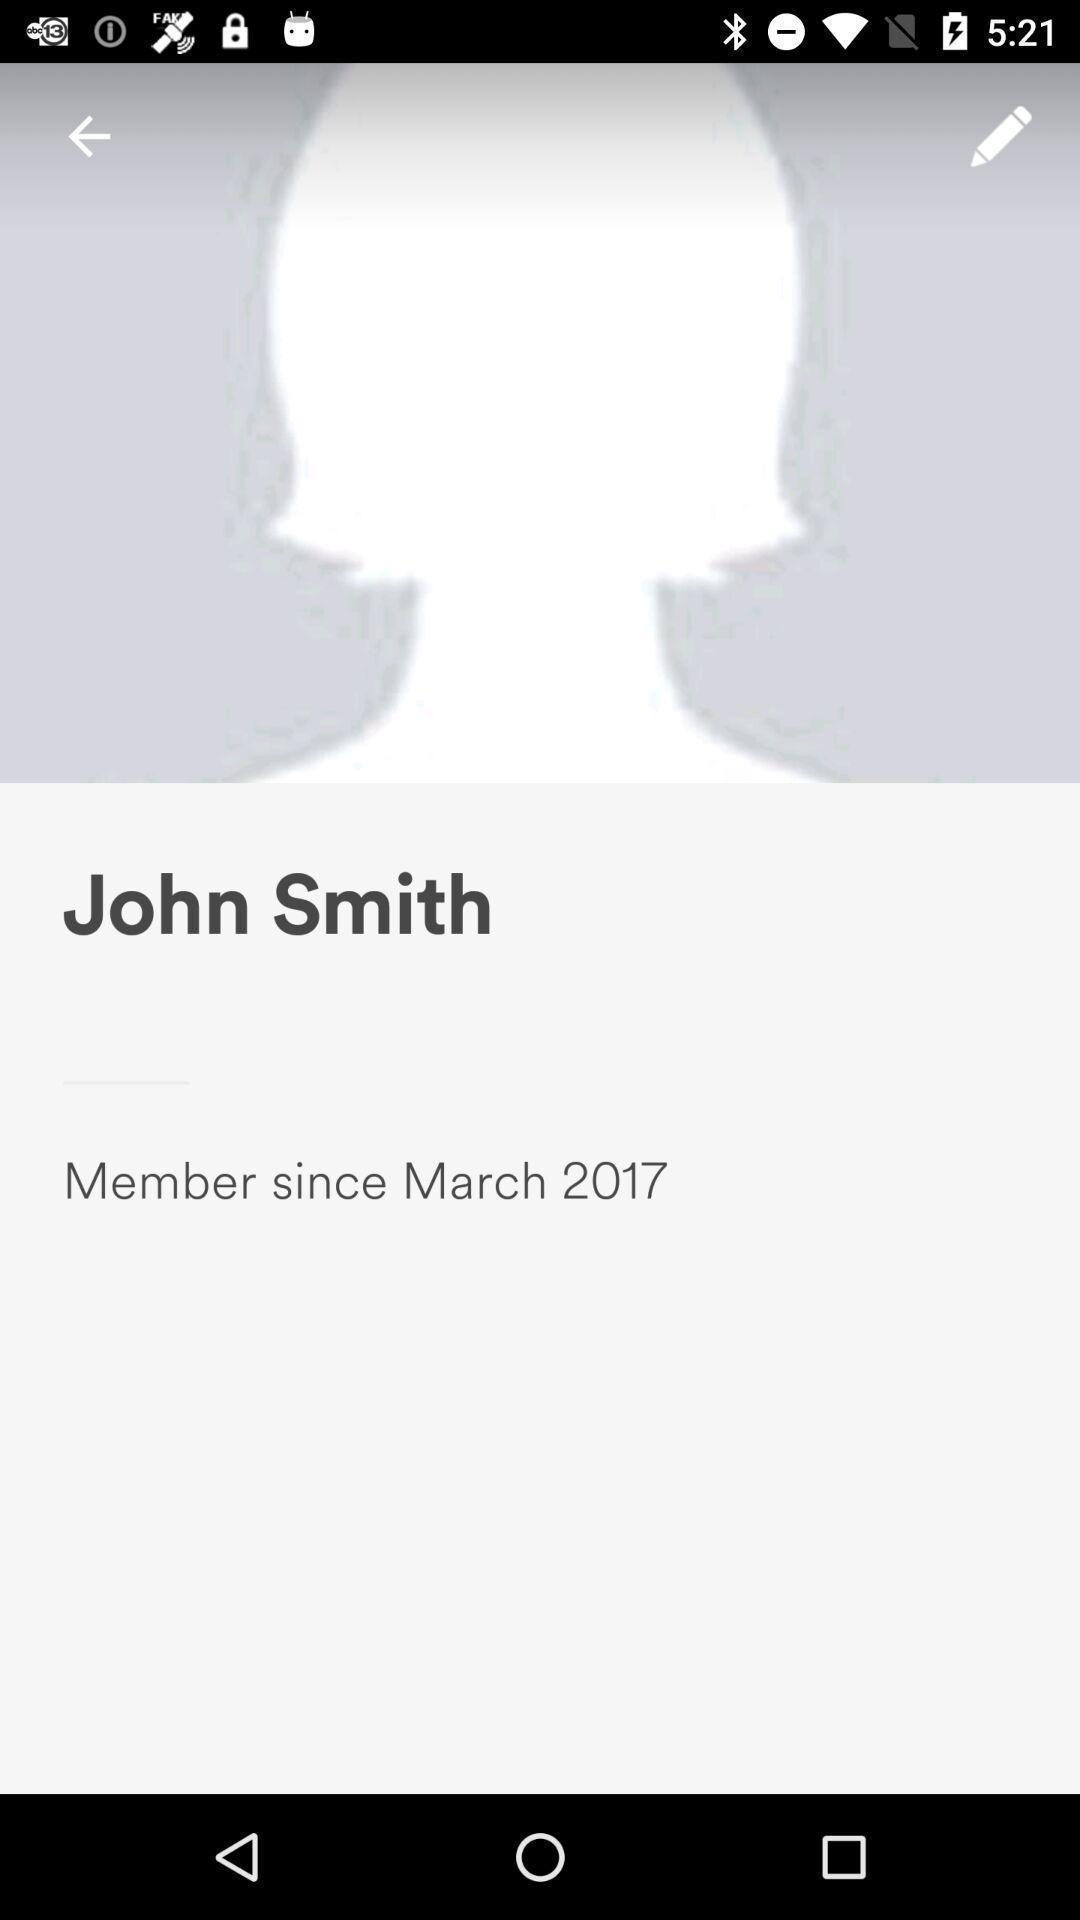Describe this image in words. Page showing the profile of john smith. 